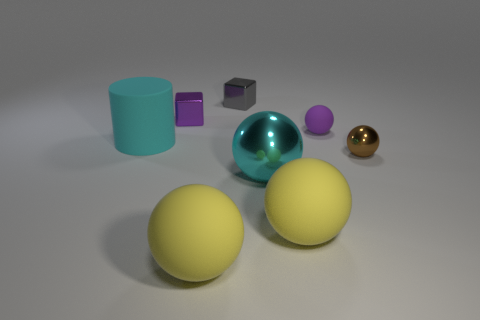Subtract all purple balls. How many balls are left? 4 Subtract all large shiny balls. How many balls are left? 4 Add 1 tiny purple rubber balls. How many objects exist? 9 Subtract all cyan spheres. Subtract all gray cylinders. How many spheres are left? 4 Subtract all blocks. How many objects are left? 6 Add 7 purple things. How many purple things are left? 9 Add 7 brown balls. How many brown balls exist? 8 Subtract 0 yellow cylinders. How many objects are left? 8 Subtract all balls. Subtract all purple spheres. How many objects are left? 2 